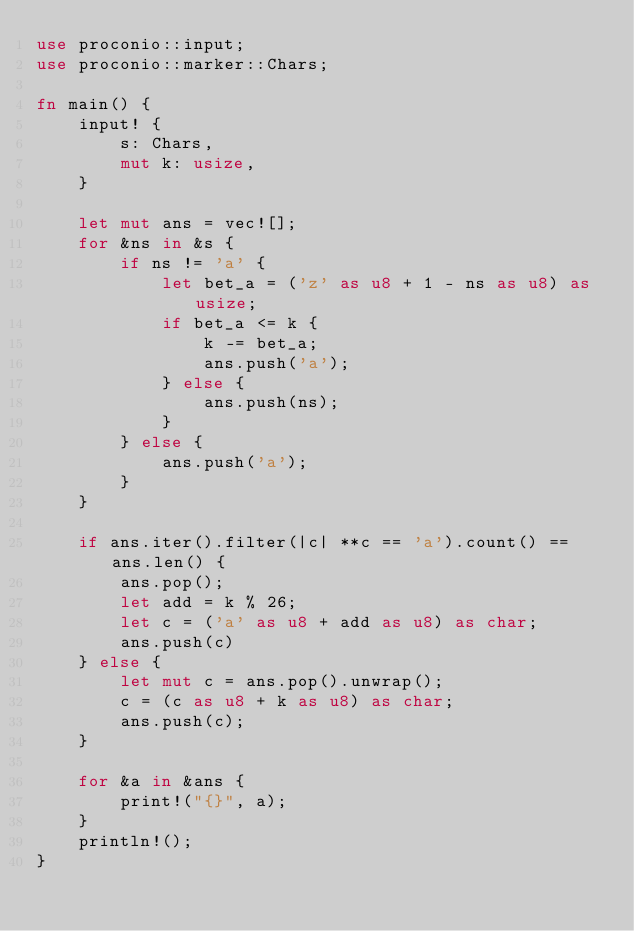<code> <loc_0><loc_0><loc_500><loc_500><_Rust_>use proconio::input;
use proconio::marker::Chars;

fn main() {
    input! {
        s: Chars,
        mut k: usize,
    }

    let mut ans = vec![];
    for &ns in &s {
        if ns != 'a' {
            let bet_a = ('z' as u8 + 1 - ns as u8) as usize;
            if bet_a <= k {
                k -= bet_a;
                ans.push('a');
            } else {
                ans.push(ns);
            }
        } else {
            ans.push('a');
        }
    }

    if ans.iter().filter(|c| **c == 'a').count() == ans.len() {
        ans.pop();
        let add = k % 26;
        let c = ('a' as u8 + add as u8) as char;
        ans.push(c)
    } else {
        let mut c = ans.pop().unwrap();
        c = (c as u8 + k as u8) as char;
        ans.push(c);
    }

    for &a in &ans {
        print!("{}", a);
    }
    println!();
}
</code> 